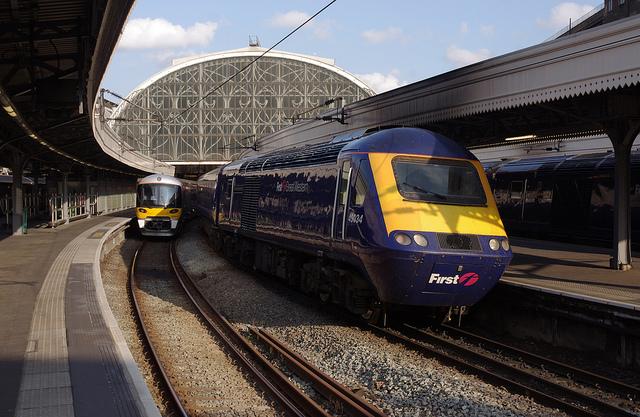Are the trains moving?
Write a very short answer. Yes. Is this a British train?
Give a very brief answer. Yes. What color is the train?
Be succinct. Blue and yellow. Are the front lights of equal brightness?
Short answer required. Yes. What kind of station is this?
Short answer required. Train. Are the trains the same?
Keep it brief. No. Is this a busy station?
Write a very short answer. No. How many trains?
Give a very brief answer. 2. Is the front of the train purple?
Give a very brief answer. Yes. 